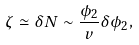<formula> <loc_0><loc_0><loc_500><loc_500>\zeta \simeq \delta N \sim \frac { \phi _ { 2 } } { v } \delta \phi _ { 2 } ,</formula> 